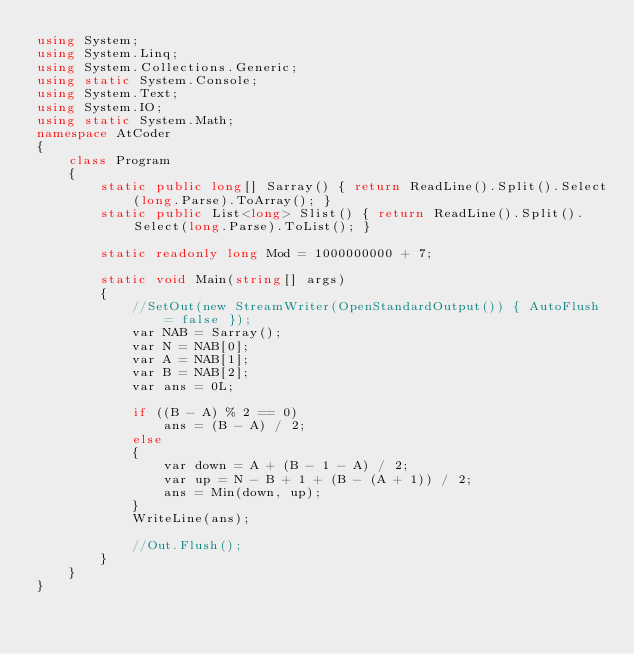<code> <loc_0><loc_0><loc_500><loc_500><_C#_>using System;
using System.Linq;
using System.Collections.Generic;
using static System.Console;
using System.Text;
using System.IO;
using static System.Math;
namespace AtCoder
{
    class Program
    {
        static public long[] Sarray() { return ReadLine().Split().Select(long.Parse).ToArray(); }
        static public List<long> Slist() { return ReadLine().Split().Select(long.Parse).ToList(); }

        static readonly long Mod = 1000000000 + 7;

        static void Main(string[] args)
        {
            //SetOut(new StreamWriter(OpenStandardOutput()) { AutoFlush = false });
            var NAB = Sarray();
            var N = NAB[0];
            var A = NAB[1];
            var B = NAB[2];
            var ans = 0L;

            if ((B - A) % 2 == 0)
                ans = (B - A) / 2;
            else
            {
                var down = A + (B - 1 - A) / 2;
                var up = N - B + 1 + (B - (A + 1)) / 2;
                ans = Min(down, up);
            }
            WriteLine(ans);

            //Out.Flush();
        }
    }
}</code> 